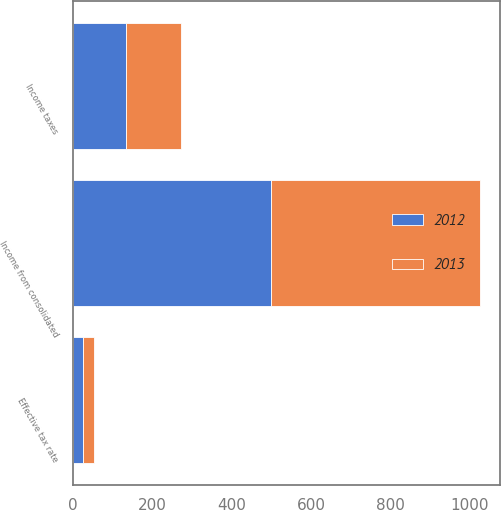Convert chart. <chart><loc_0><loc_0><loc_500><loc_500><stacked_bar_chart><ecel><fcel>Income from consolidated<fcel>Income taxes<fcel>Effective tax rate<nl><fcel>2012<fcel>499.4<fcel>133.6<fcel>26.8<nl><fcel>2013<fcel>526.1<fcel>139.8<fcel>26.6<nl></chart> 